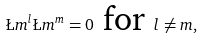Convert formula to latex. <formula><loc_0><loc_0><loc_500><loc_500>\L m ^ { l } \L m ^ { m } = 0 \text { for } l \neq m ,</formula> 